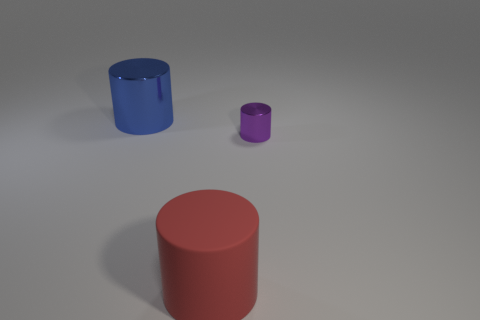Subtract all metallic cylinders. How many cylinders are left? 1 Subtract all blue cylinders. How many cylinders are left? 2 Add 1 tiny yellow rubber cylinders. How many objects exist? 4 Subtract 0 green cylinders. How many objects are left? 3 Subtract 1 cylinders. How many cylinders are left? 2 Subtract all cyan cylinders. Subtract all red balls. How many cylinders are left? 3 Subtract all tiny purple cylinders. Subtract all rubber cubes. How many objects are left? 2 Add 3 big blue things. How many big blue things are left? 4 Add 2 purple shiny objects. How many purple shiny objects exist? 3 